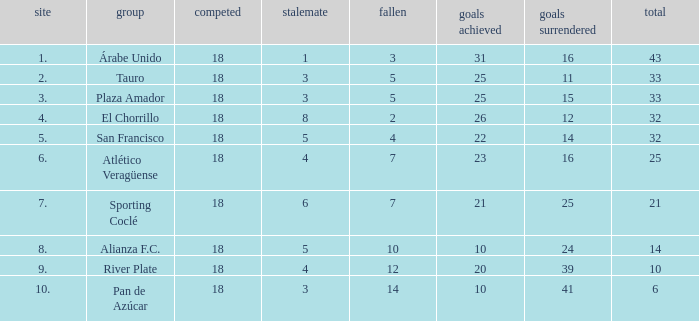How many points did the team have that conceded 41 goals and finish in a place larger than 10? 0.0. 